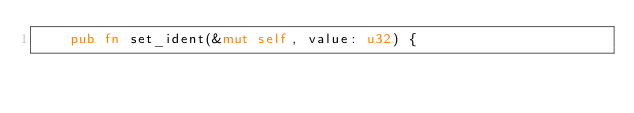<code> <loc_0><loc_0><loc_500><loc_500><_Rust_>    pub fn set_ident(&mut self, value: u32) {</code> 